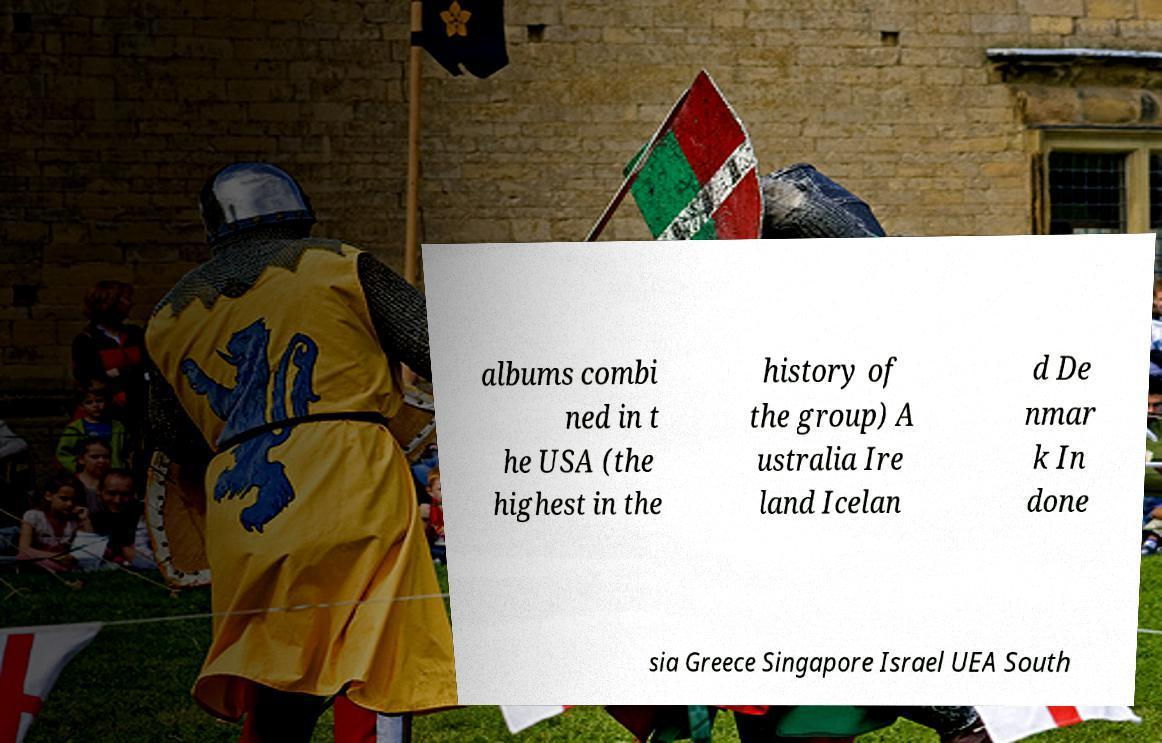There's text embedded in this image that I need extracted. Can you transcribe it verbatim? albums combi ned in t he USA (the highest in the history of the group) A ustralia Ire land Icelan d De nmar k In done sia Greece Singapore Israel UEA South 